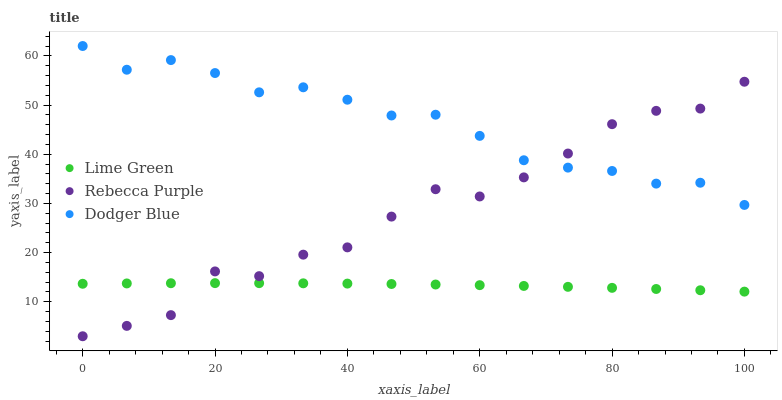Does Lime Green have the minimum area under the curve?
Answer yes or no. Yes. Does Dodger Blue have the maximum area under the curve?
Answer yes or no. Yes. Does Rebecca Purple have the minimum area under the curve?
Answer yes or no. No. Does Rebecca Purple have the maximum area under the curve?
Answer yes or no. No. Is Lime Green the smoothest?
Answer yes or no. Yes. Is Rebecca Purple the roughest?
Answer yes or no. Yes. Is Rebecca Purple the smoothest?
Answer yes or no. No. Is Lime Green the roughest?
Answer yes or no. No. Does Rebecca Purple have the lowest value?
Answer yes or no. Yes. Does Lime Green have the lowest value?
Answer yes or no. No. Does Dodger Blue have the highest value?
Answer yes or no. Yes. Does Rebecca Purple have the highest value?
Answer yes or no. No. Is Lime Green less than Dodger Blue?
Answer yes or no. Yes. Is Dodger Blue greater than Lime Green?
Answer yes or no. Yes. Does Rebecca Purple intersect Lime Green?
Answer yes or no. Yes. Is Rebecca Purple less than Lime Green?
Answer yes or no. No. Is Rebecca Purple greater than Lime Green?
Answer yes or no. No. Does Lime Green intersect Dodger Blue?
Answer yes or no. No. 